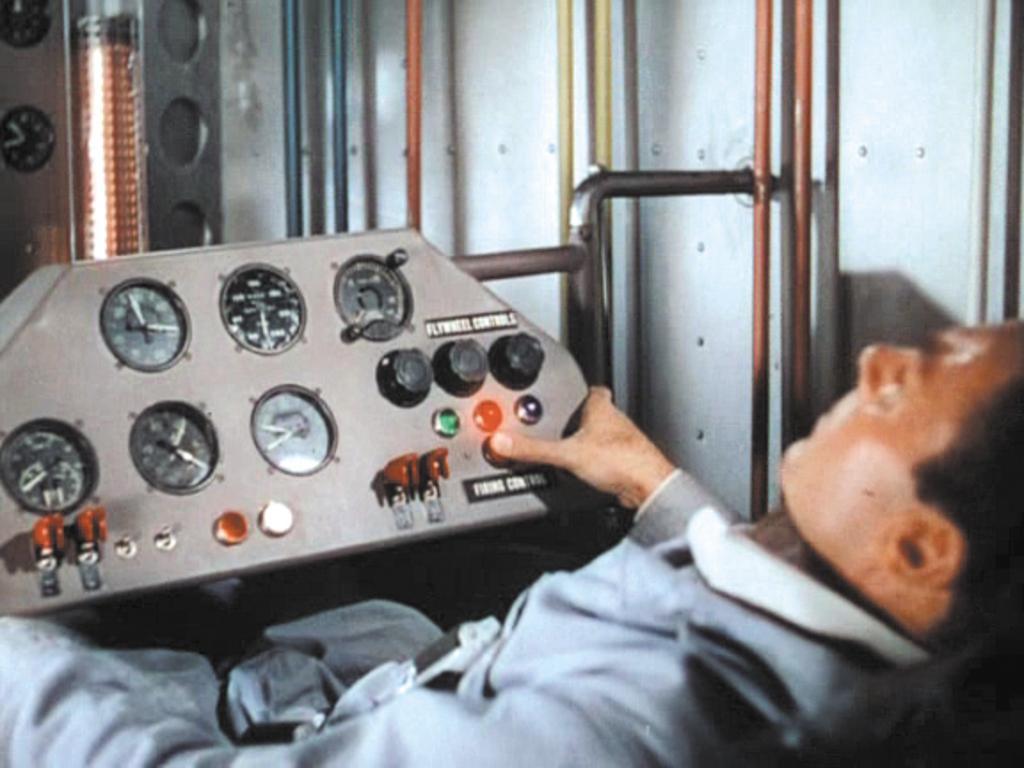In one or two sentences, can you explain what this image depicts? In this image we can see a person touching the speedometer board, walls and some pipelines attached to the wall. 